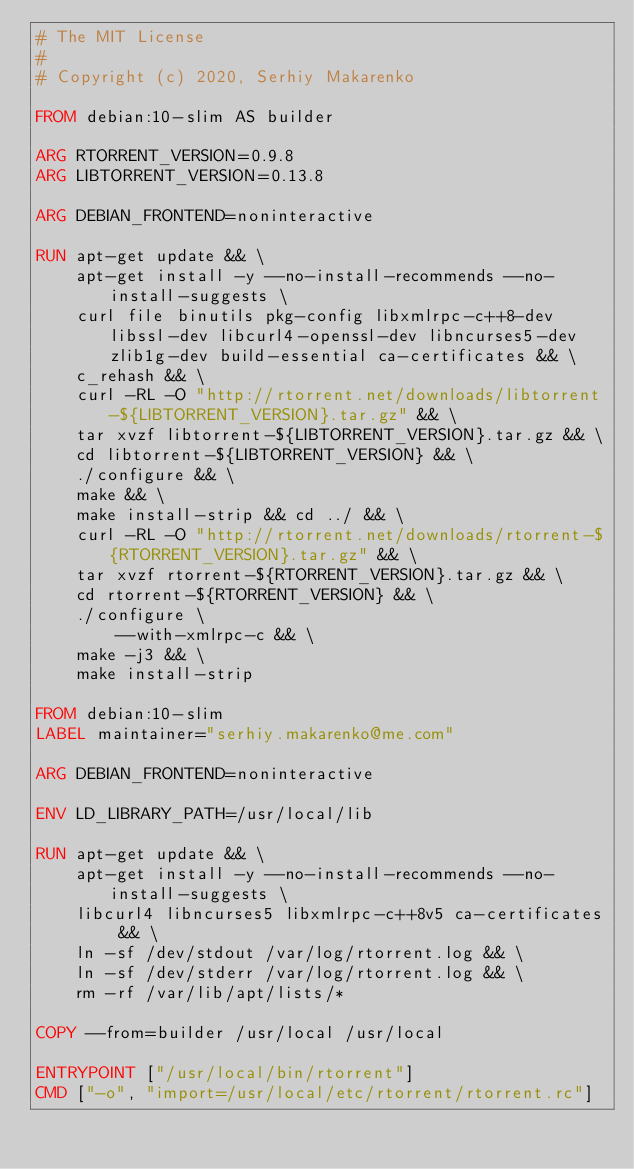Convert code to text. <code><loc_0><loc_0><loc_500><loc_500><_Dockerfile_># The MIT License
#
# Copyright (c) 2020, Serhiy Makarenko

FROM debian:10-slim AS builder

ARG RTORRENT_VERSION=0.9.8
ARG LIBTORRENT_VERSION=0.13.8

ARG DEBIAN_FRONTEND=noninteractive

RUN apt-get update && \
    apt-get install -y --no-install-recommends --no-install-suggests \
    curl file binutils pkg-config libxmlrpc-c++8-dev libssl-dev libcurl4-openssl-dev libncurses5-dev zlib1g-dev build-essential ca-certificates && \
    c_rehash && \
    curl -RL -O "http://rtorrent.net/downloads/libtorrent-${LIBTORRENT_VERSION}.tar.gz" && \
    tar xvzf libtorrent-${LIBTORRENT_VERSION}.tar.gz && \
    cd libtorrent-${LIBTORRENT_VERSION} && \
    ./configure && \
    make && \
    make install-strip && cd ../ && \
    curl -RL -O "http://rtorrent.net/downloads/rtorrent-${RTORRENT_VERSION}.tar.gz" && \
    tar xvzf rtorrent-${RTORRENT_VERSION}.tar.gz && \
    cd rtorrent-${RTORRENT_VERSION} && \
    ./configure \
        --with-xmlrpc-c && \
    make -j3 && \
    make install-strip

FROM debian:10-slim
LABEL maintainer="serhiy.makarenko@me.com"

ARG DEBIAN_FRONTEND=noninteractive

ENV LD_LIBRARY_PATH=/usr/local/lib

RUN apt-get update && \
    apt-get install -y --no-install-recommends --no-install-suggests \
    libcurl4 libncurses5 libxmlrpc-c++8v5 ca-certificates && \
    ln -sf /dev/stdout /var/log/rtorrent.log && \
    ln -sf /dev/stderr /var/log/rtorrent.log && \
    rm -rf /var/lib/apt/lists/*

COPY --from=builder /usr/local /usr/local

ENTRYPOINT ["/usr/local/bin/rtorrent"]
CMD ["-o", "import=/usr/local/etc/rtorrent/rtorrent.rc"]
</code> 